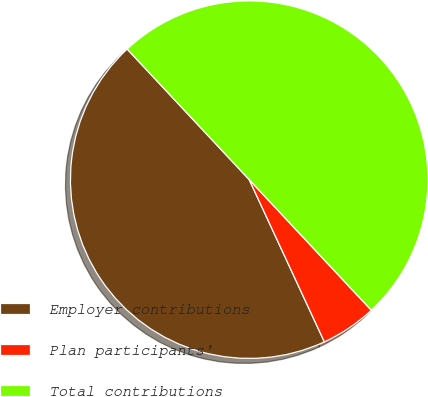Convert chart. <chart><loc_0><loc_0><loc_500><loc_500><pie_chart><fcel>Employer contributions<fcel>Plan participants'<fcel>Total contributions<nl><fcel>44.94%<fcel>5.06%<fcel>50.0%<nl></chart> 